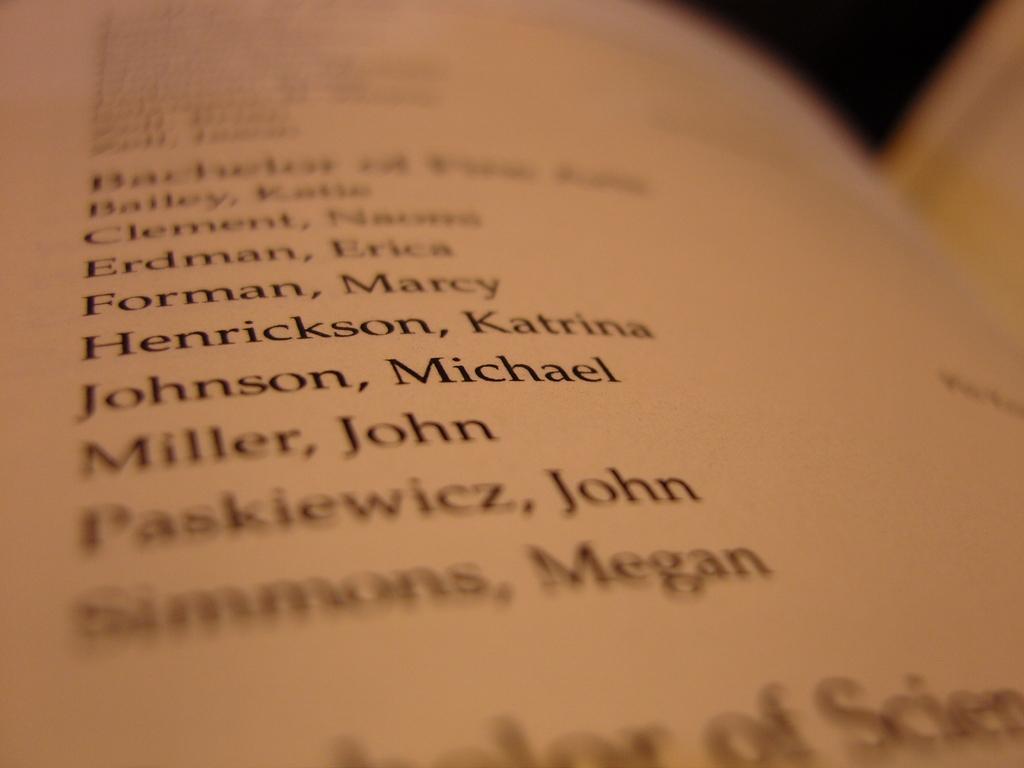Could you give a brief overview of what you see in this image? In this image we can see the script which is written in the book. 